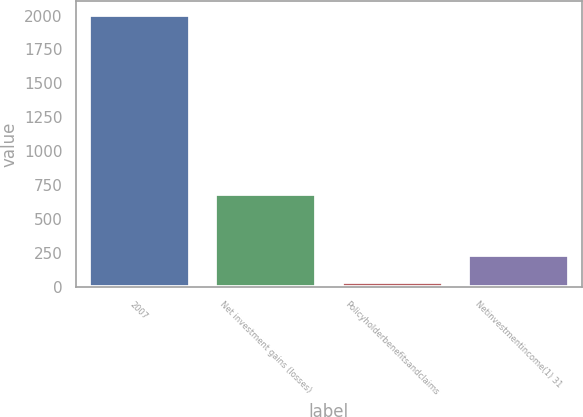Convert chart to OTSL. <chart><loc_0><loc_0><loc_500><loc_500><bar_chart><fcel>2007<fcel>Net investment gains (losses)<fcel>Policyholderbenefitsandclaims<fcel>Netinvestmentincome(1) 31<nl><fcel>2006<fcel>685<fcel>33<fcel>230.3<nl></chart> 